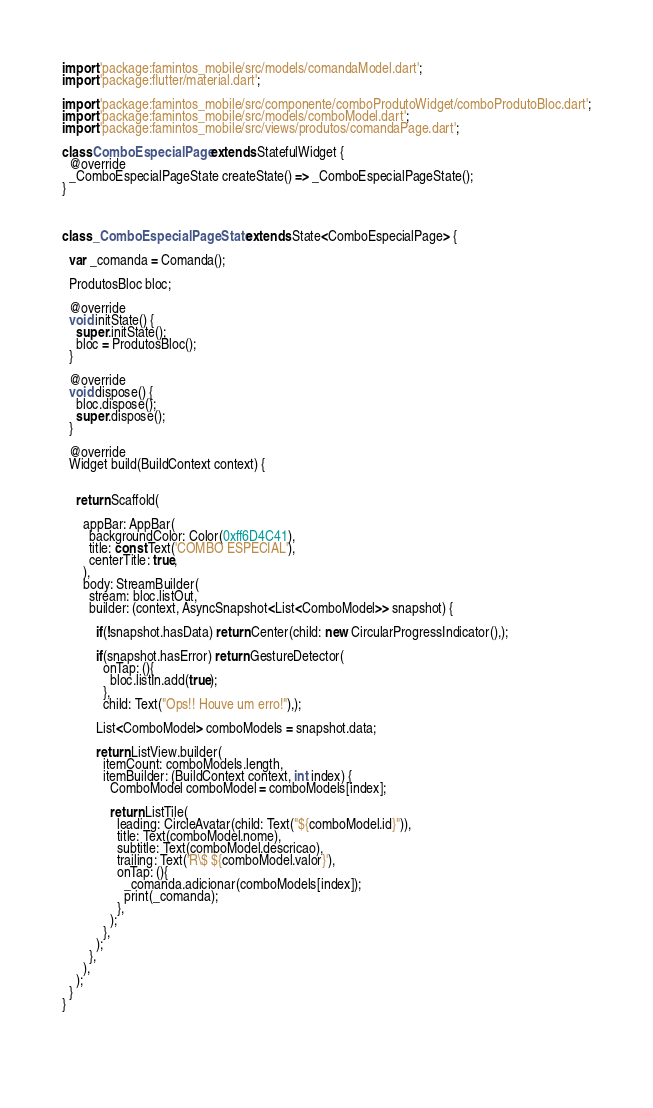<code> <loc_0><loc_0><loc_500><loc_500><_Dart_>
import 'package:famintos_mobile/src/models/comandaModel.dart';
import 'package:flutter/material.dart';

import 'package:famintos_mobile/src/componente/comboProdutoWidget/comboProdutoBloc.dart';
import 'package:famintos_mobile/src/models/comboModel.dart';
import 'package:famintos_mobile/src/views/produtos/comandaPage.dart';

class ComboEspecialPage extends StatefulWidget {
  @override
  _ComboEspecialPageState createState() => _ComboEspecialPageState();
}



class _ComboEspecialPageState extends State<ComboEspecialPage> {

  var _comanda = Comanda();

  ProdutosBloc bloc;

  @override
  void initState() {
    super.initState();
    bloc = ProdutosBloc();
  }

  @override
  void dispose() {
    bloc.dispose();
    super.dispose();
  }

  @override
  Widget build(BuildContext context) {
    

    return Scaffold(
      
      appBar: AppBar(
        backgroundColor: Color(0xff6D4C41),
        title: const Text('COMBO ESPECIAL'),
        centerTitle: true,
      ),
      body: StreamBuilder(
        stream: bloc.listOut,
        builder: (context, AsyncSnapshot<List<ComboModel>> snapshot) {

          if(!snapshot.hasData) return Center(child: new CircularProgressIndicator(),);

          if(snapshot.hasError) return GestureDetector(
            onTap: (){
              bloc.listIn.add(true);
            },
            child: Text("Ops!! Houve um erro!"),);

          List<ComboModel> comboModels = snapshot.data; 

          return ListView.builder(
            itemCount: comboModels.length, 
            itemBuilder: (BuildContext context, int index) {
              ComboModel comboModel = comboModels[index];

              return ListTile(
                leading: CircleAvatar(child: Text("${comboModel.id}")),
                title: Text(comboModel.nome),
                subtitle: Text(comboModel.descricao),
                trailing: Text('R\$ ${comboModel.valor}'),
                onTap: (){
                  _comanda.adicionar(comboModels[index]);
                  print(_comanda);
                },
              );
            },
          );
        },
      ),
    );
  }
}


              </code> 